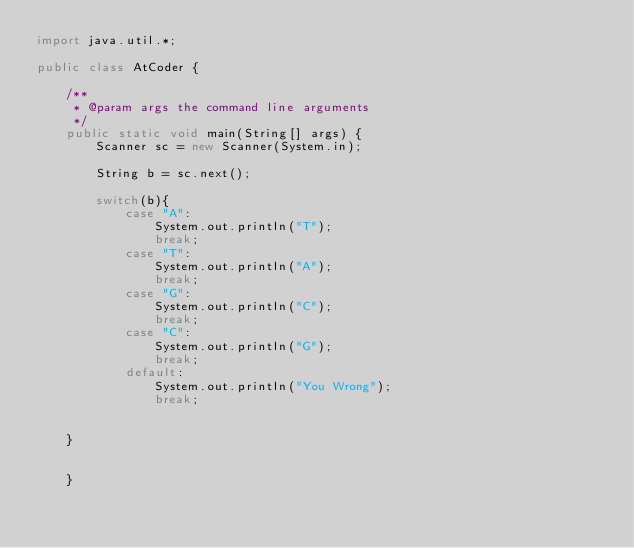<code> <loc_0><loc_0><loc_500><loc_500><_Java_>import java.util.*;

public class AtCoder {

    /**
     * @param args the command line arguments
     */
    public static void main(String[] args) {
        Scanner sc = new Scanner(System.in);
        
        String b = sc.next();
        
        switch(b){
            case "A":
                System.out.println("T");
                break;
            case "T":
                System.out.println("A");
                break;
            case "G":
                System.out.println("C");
                break;
            case "C":
                System.out.println("G");
                break;
            default:
                System.out.println("You Wrong");
            	break;
                
        
    }
        
        
    }</code> 